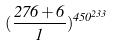Convert formula to latex. <formula><loc_0><loc_0><loc_500><loc_500>( \frac { 2 7 6 + 6 } { 1 } ) ^ { 4 5 0 ^ { 2 3 3 } }</formula> 